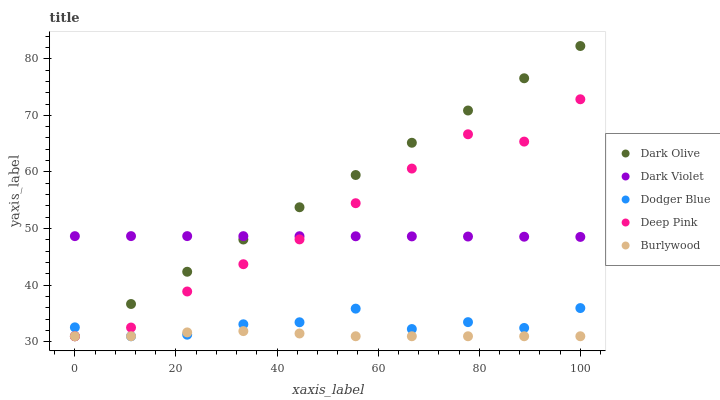Does Burlywood have the minimum area under the curve?
Answer yes or no. Yes. Does Dark Olive have the maximum area under the curve?
Answer yes or no. Yes. Does Dodger Blue have the minimum area under the curve?
Answer yes or no. No. Does Dodger Blue have the maximum area under the curve?
Answer yes or no. No. Is Dark Olive the smoothest?
Answer yes or no. Yes. Is Deep Pink the roughest?
Answer yes or no. Yes. Is Dodger Blue the smoothest?
Answer yes or no. No. Is Dodger Blue the roughest?
Answer yes or no. No. Does Burlywood have the lowest value?
Answer yes or no. Yes. Does Dark Violet have the lowest value?
Answer yes or no. No. Does Dark Olive have the highest value?
Answer yes or no. Yes. Does Dodger Blue have the highest value?
Answer yes or no. No. Is Dodger Blue less than Dark Violet?
Answer yes or no. Yes. Is Dark Violet greater than Burlywood?
Answer yes or no. Yes. Does Burlywood intersect Dodger Blue?
Answer yes or no. Yes. Is Burlywood less than Dodger Blue?
Answer yes or no. No. Is Burlywood greater than Dodger Blue?
Answer yes or no. No. Does Dodger Blue intersect Dark Violet?
Answer yes or no. No. 